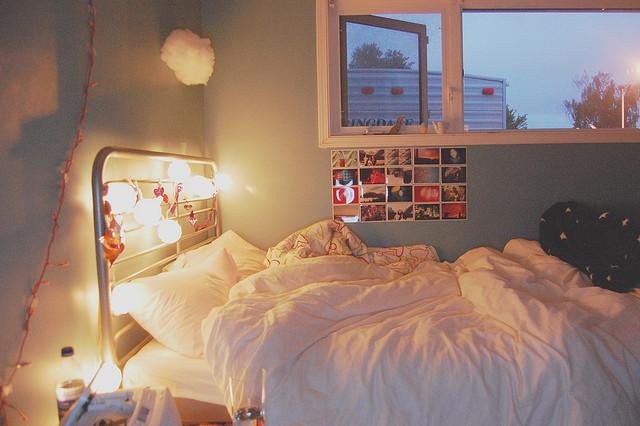What color is the bed sheet?
Answer briefly. White. Is the headboard made of metal?
Quick response, please. Yes. What color is the headboard?
Concise answer only. Silver. What color is the blanket on the bed?
Keep it brief. White. Is the candle on?
Keep it brief. No. Is the blanket colorful?
Give a very brief answer. No. Is the room messy or neat?
Quick response, please. Messy. Is it sunny or overcast?
Keep it brief. Overcast. Is anyone in the bed?
Write a very short answer. No. Might this be a motel/hotel?
Write a very short answer. No. What is the bed made of?
Write a very short answer. Metal. Is there a list of U.S.A leaders in this picture?
Answer briefly. No. Does the bedspread have a pattern?
Be succinct. No. What are the bed sheets for?
Give a very brief answer. Comfort. What is the white fluffy thing above the bed?
Keep it brief. Cloud. Is this a girl's room or a boy's room?
Give a very brief answer. Girl. Is it day or night outside?
Concise answer only. Night. Is the house tidy?
Short answer required. No. Are there more than 2 pillows on the bed?
Give a very brief answer. Yes. Is there a person standing on the headboard of the bed?
Write a very short answer. No. 